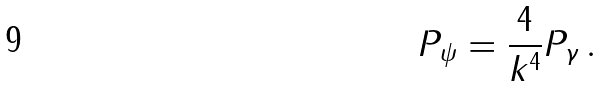Convert formula to latex. <formula><loc_0><loc_0><loc_500><loc_500>P _ { \psi } = \frac { 4 } { k ^ { 4 } } P _ { \gamma } \, .</formula> 